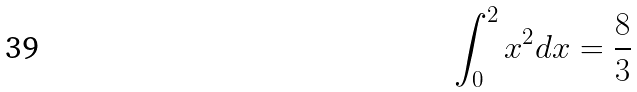<formula> <loc_0><loc_0><loc_500><loc_500>\int _ { 0 } ^ { 2 } x ^ { 2 } d x = \frac { 8 } { 3 }</formula> 